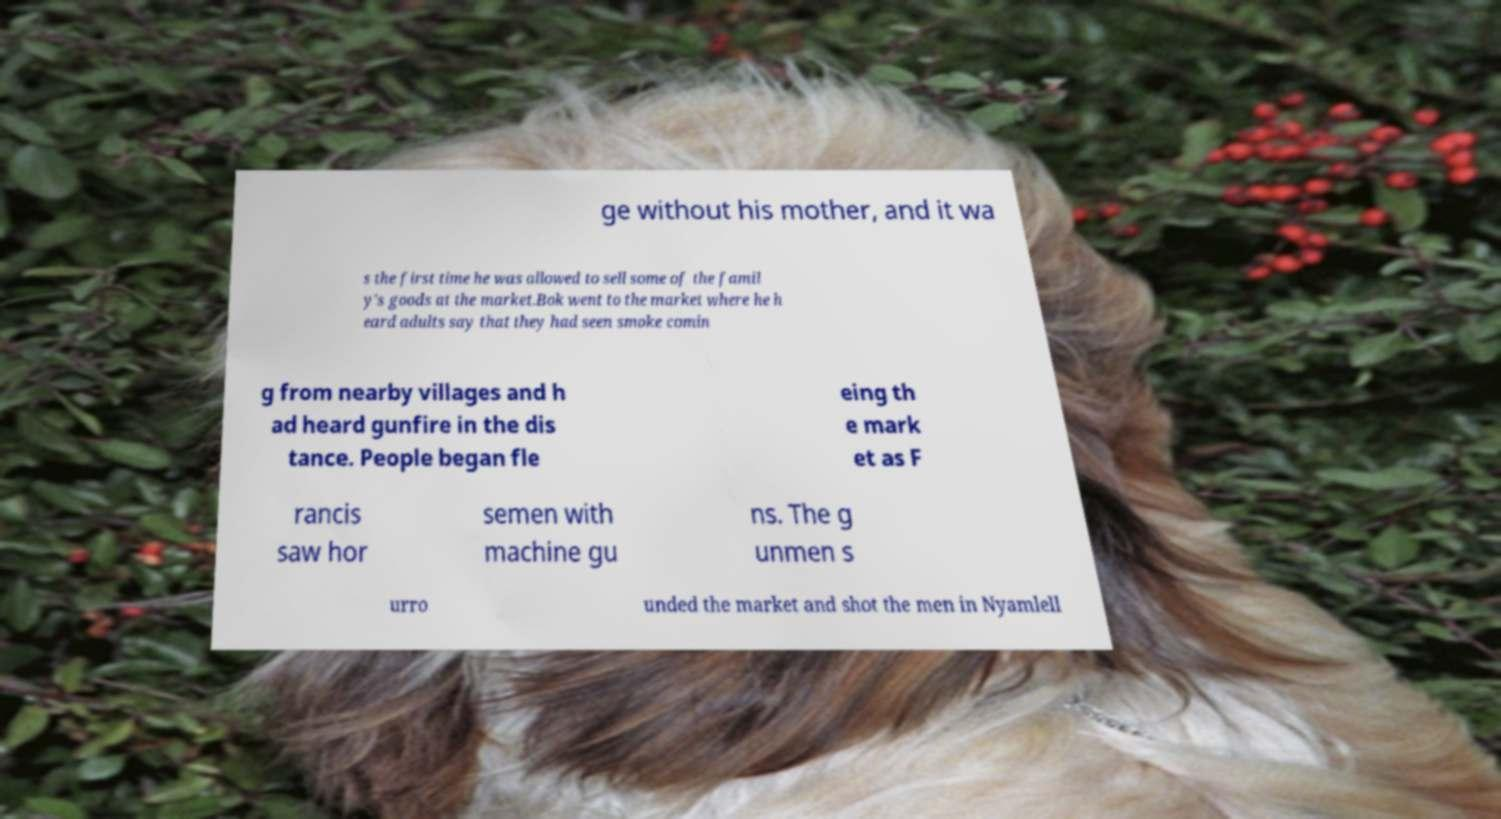What messages or text are displayed in this image? I need them in a readable, typed format. ge without his mother, and it wa s the first time he was allowed to sell some of the famil y's goods at the market.Bok went to the market where he h eard adults say that they had seen smoke comin g from nearby villages and h ad heard gunfire in the dis tance. People began fle eing th e mark et as F rancis saw hor semen with machine gu ns. The g unmen s urro unded the market and shot the men in Nyamlell 